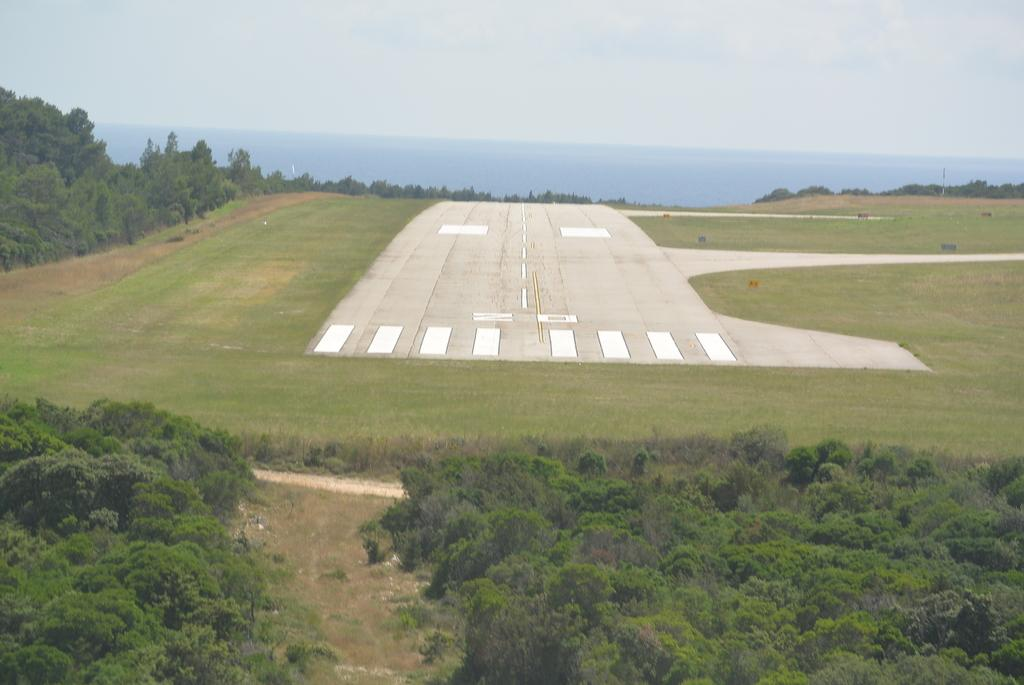What is the main feature in the middle of the image? There is a runway in the middle of the image. What type of terrain surrounds the runway? Grassland is present on either side of the runway. What can be seen in the background of the image? Trees are visible in the front and back of the image. What is visible above the runway? The sky is visible above the runway. What type of prison can be seen in the image? There is no prison present in the image; it features a runway with grassland, trees, and sky. What kind of apparel is being worn by the trees in the image? Trees do not wear apparel; they are natural vegetation. 